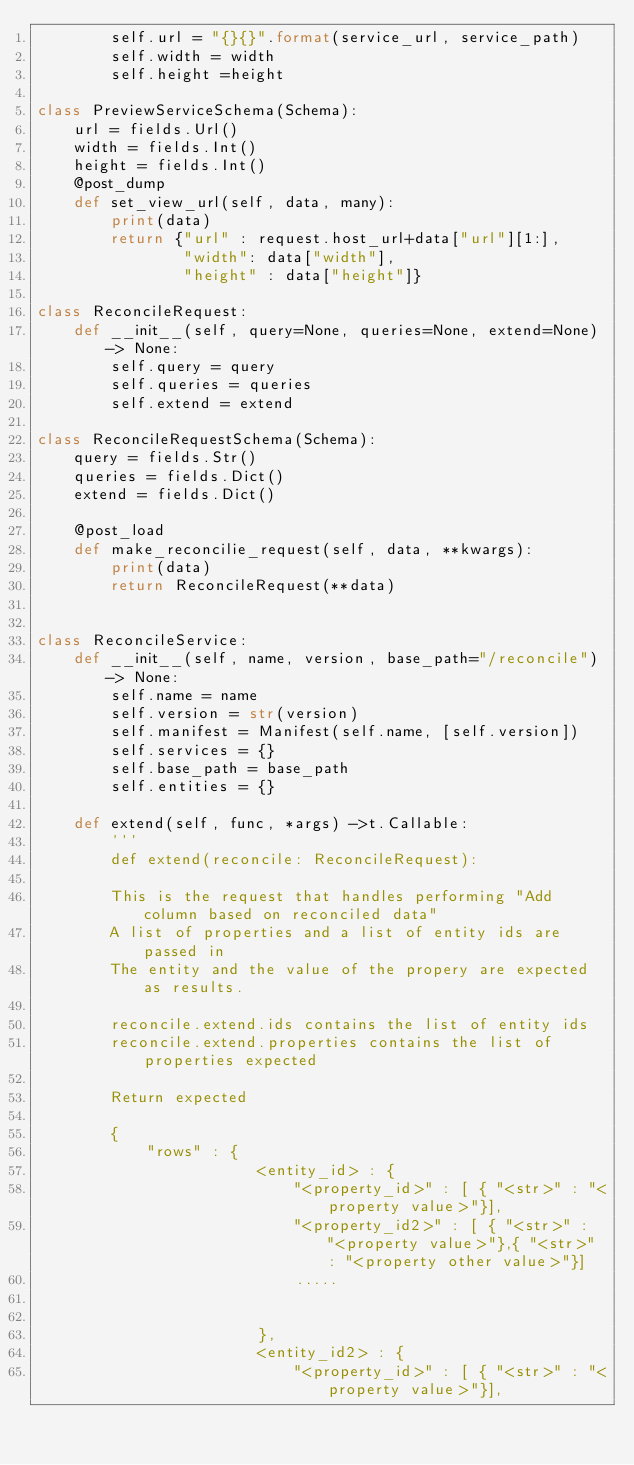<code> <loc_0><loc_0><loc_500><loc_500><_Python_>        self.url = "{}{}".format(service_url, service_path)
        self.width = width
        self.height =height

class PreviewServiceSchema(Schema):
    url = fields.Url()
    width = fields.Int()
    height = fields.Int()
    @post_dump
    def set_view_url(self, data, many):
        print(data)
        return {"url" : request.host_url+data["url"][1:],
                "width": data["width"],
                "height" : data["height"]}

class ReconcileRequest:
    def __init__(self, query=None, queries=None, extend=None) -> None:
        self.query = query
        self.queries = queries
        self.extend = extend

class ReconcileRequestSchema(Schema):
    query = fields.Str()
    queries = fields.Dict()
    extend = fields.Dict()
    
    @post_load
    def make_reconcilie_request(self, data, **kwargs):
        print(data)
        return ReconcileRequest(**data)
    

class ReconcileService: 
    def __init__(self, name, version, base_path="/reconcile") -> None:
        self.name = name
        self.version = str(version)
        self.manifest = Manifest(self.name, [self.version])
        self.services = {}
        self.base_path = base_path
        self.entities = {}
        
    def extend(self, func, *args) ->t.Callable:
        '''
        def extend(reconcile: ReconcileRequest):

        This is the request that handles performing "Add column based on reconciled data"
        A list of properties and a list of entity ids are passed in 
        The entity and the value of the propery are expected as results.

        reconcile.extend.ids contains the list of entity ids
        reconcile.extend.properties contains the list of properties expected

        Return expected

        {
            "rows" : {
                        <entity_id> : {
                            "<property_id>" : [ { "<str>" : "<property value>"}],
                            "<property_id2>" : [ { "<str>" : "<property value>"},{ "<str>" : "<property other value>"}]
                            .....
                            

                        },
                        <entity_id2> : {
                            "<property_id>" : [ { "<str>" : "<property value>"}],</code> 